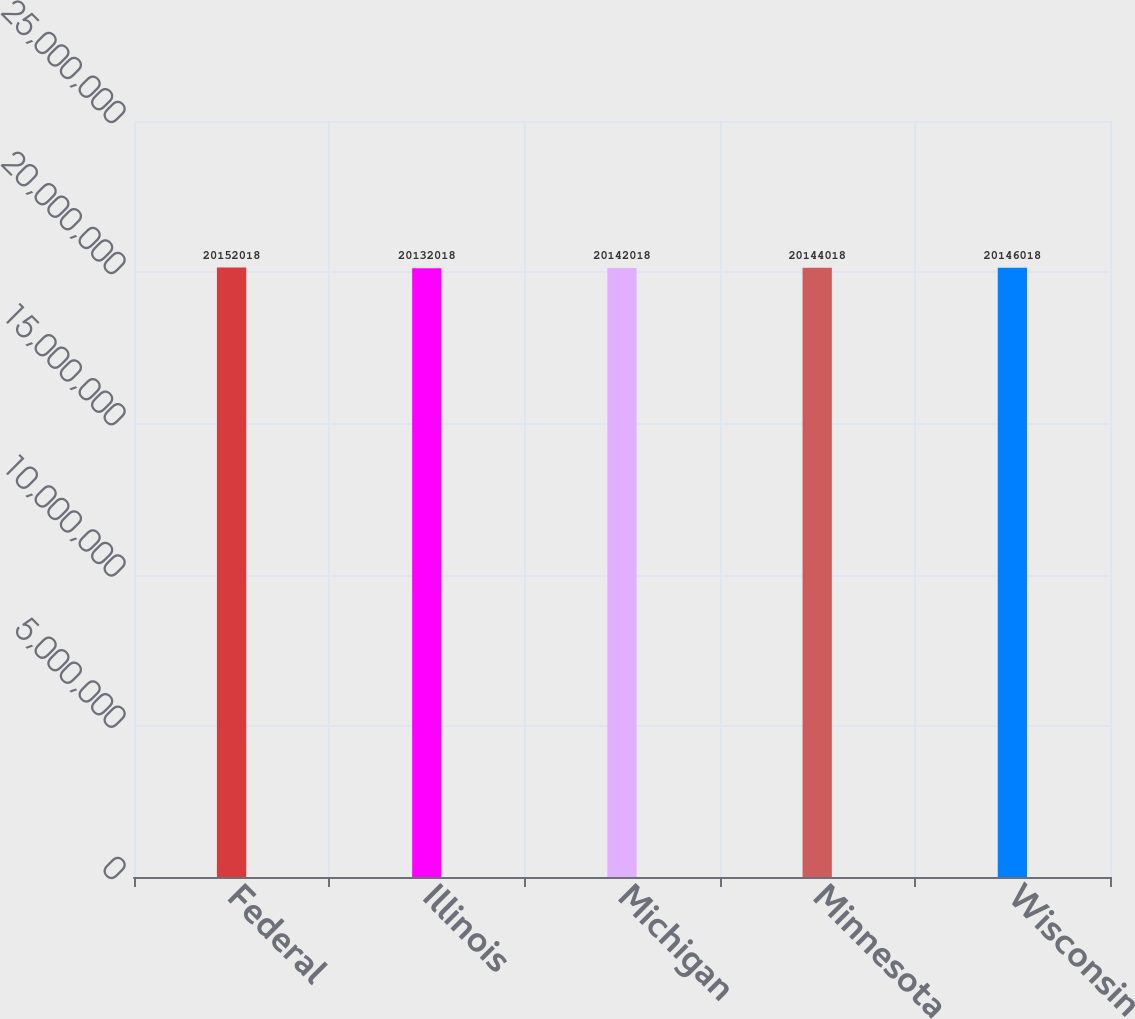Convert chart. <chart><loc_0><loc_0><loc_500><loc_500><bar_chart><fcel>Federal<fcel>Illinois<fcel>Michigan<fcel>Minnesota<fcel>Wisconsin<nl><fcel>2.0152e+07<fcel>2.0132e+07<fcel>2.0142e+07<fcel>2.0144e+07<fcel>2.0146e+07<nl></chart> 